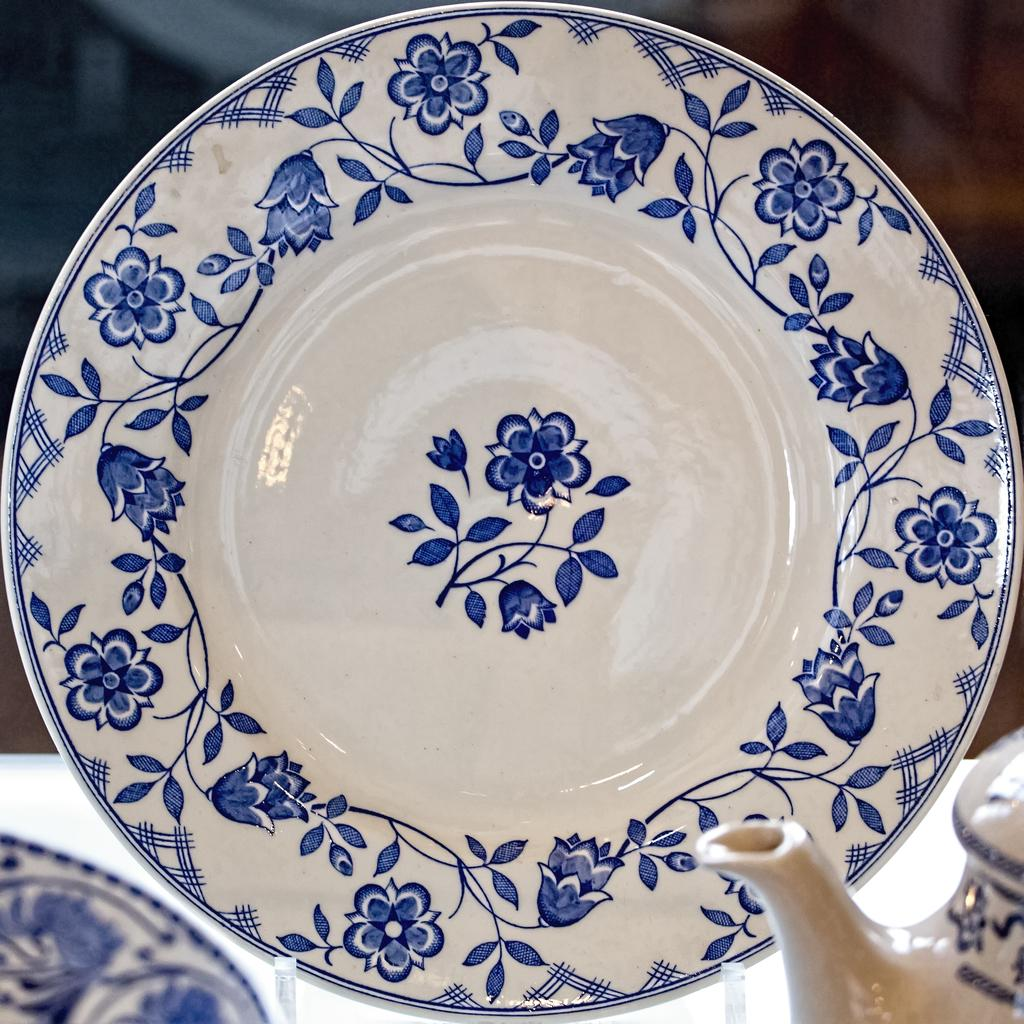What is placed on a stand in the image? There is a serving plate placed on a stand in the image. What can be seen in the foreground of the image? There is a teapot in the foreground of the image. What type of destruction can be seen happening to the teapot in the image? There is no destruction happening to the teapot in the image; it is intact and visible in the foreground. How much credit is given to the serving plate in the image? The image does not assign credit to any objects, including the serving plate. 